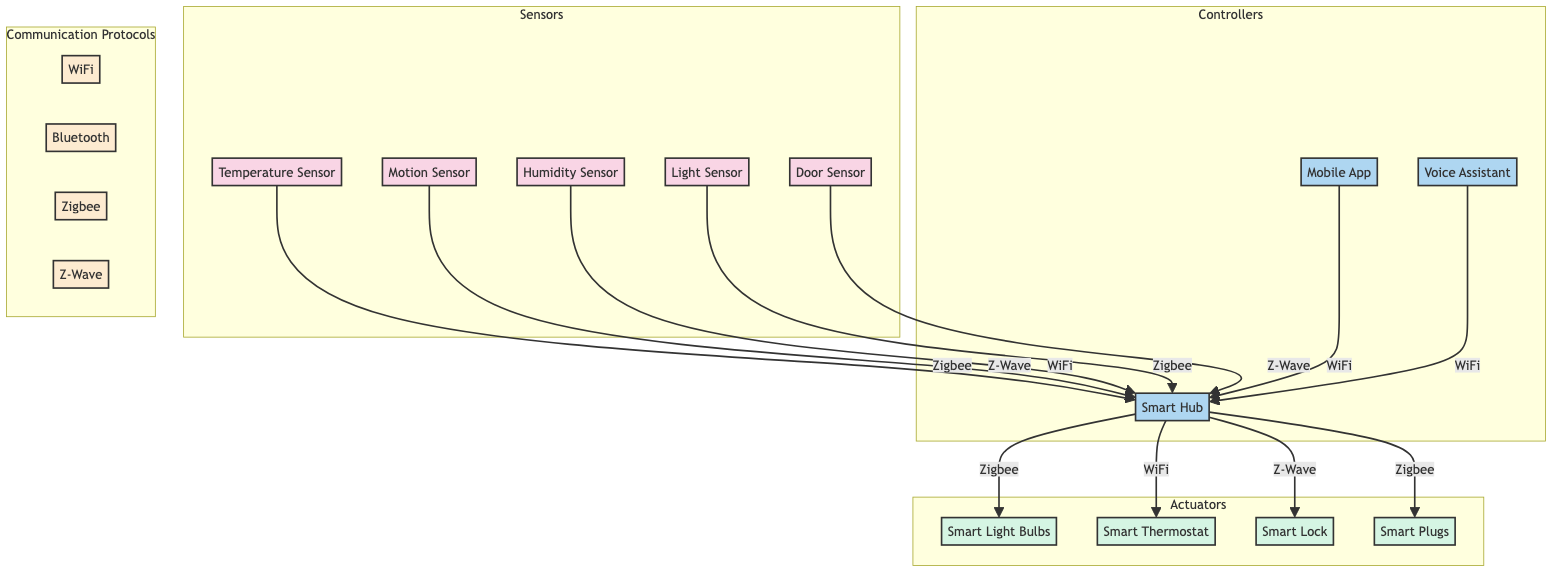What are the sensors used in the system? The sensors listed in the diagram are Temperature Sensor, Motion Sensor, Humidity Sensor, Light Sensor, and Door Sensor.
Answer: Temperature Sensor, Motion Sensor, Humidity Sensor, Light Sensor, Door Sensor How many controllers are present in the system? The diagram shows three controllers: Smart Hub, Mobile App, and Voice Assistant.
Answer: 3 Which protocol is used for communication from the Humidity Sensor to the Smart Hub? According to the diagram, the Humidity Sensor communicates with the Smart Hub using the WiFi protocol.
Answer: WiFi How many actuators are in the system? The diagram identifies four actuators: Smart Light Bulbs, Smart Thermostat, Smart Lock, and Smart Plugs, hence there are four actuators in total.
Answer: 4 Which controller communicates with the Smart Light Bulbs? The Smart Light Bulbs are controlled by the Smart Hub, as indicated in the communication flow of the diagram.
Answer: Smart Hub What is the communication protocol used between the Motion Sensor and the Smart Hub? The diagram specifies that the Motion Sensor communicates with the Smart Hub using the Z-Wave protocol.
Answer: Z-Wave Which component receives commands from the Mobile App? The diagram shows that the Mobile App sends commands to the Smart Hub.
Answer: Smart Hub How many communication protocols are listed in the diagram? The communication protocols represented in the diagram are WiFi, Bluetooth, Zigbee, and Z-Wave, totaling four protocols.
Answer: 4 Which sensor uses Zigbee to communicate? The diagram indicates that both the Temperature Sensor and Light Sensor communicate with the Smart Hub using the Zigbee protocol.
Answer: Temperature Sensor, Light Sensor 